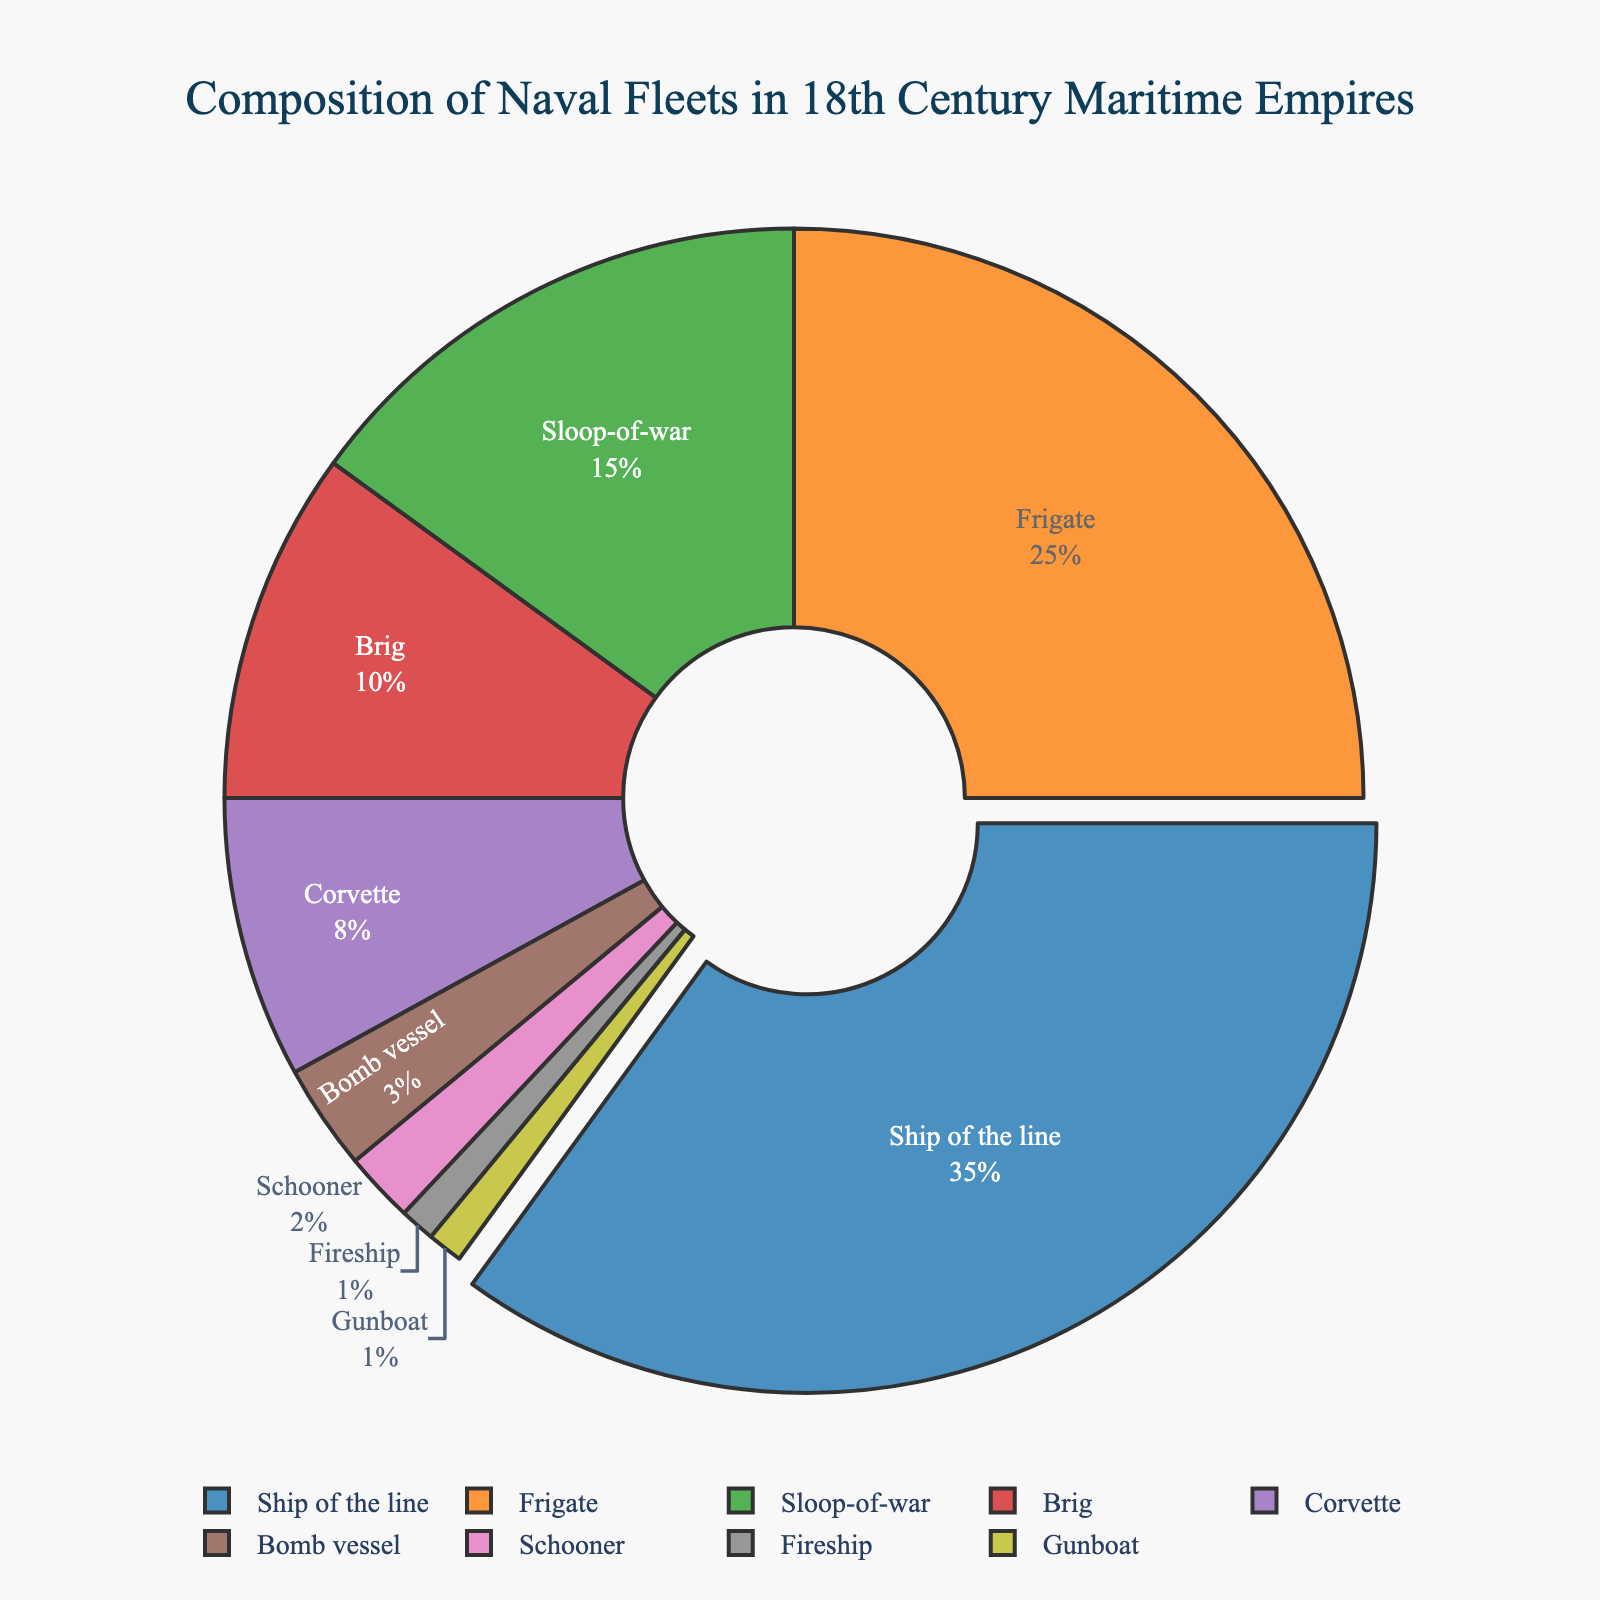What is the most common ship class in the 18th-century naval fleets? First, identify the ship class with the highest percentage in the pie chart. The "Ship of the line" makes up 35% of the fleet, which is the largest share.
Answer: Ship of the line What is the combined percentage of Brigs, Corvettes, and Bomb vessels? Add the percentages of Brigs (10%), Corvettes (8%), and Bomb vessels (3%). So, 10% + 8% + 3% = 21%.
Answer: 21% Are Frigates more common than Sloops-of-war, and by what percentage? Compare the percentages of Frigates (25%) and Sloops-of-war (15%). The difference is 25% - 15% = 10%.
Answer: Yes, by 10% What percentage of the fleet is made up by the three least common ship classes? Identify the three least common ship classes: Fireship (1%), Gunboat (1%), and Schooner (2%). The combined percentage is 1% + 1% + 2% = 4%.
Answer: 4% Which ship classes together make up more than half of the fleet's composition? Add the percentages iteratively until the sum exceeds 50%. Ships of the line (35%) + Frigates (25%) = 60%.
Answer: Ships of the line and Frigates Which ship class is represented by the green color in the pie chart? In the pie chart, each segment is color-coded. According to the provided data, the third listed class after the corresponding colors (‘#2ca02c’) would be the Sloop-of-war, which is green.
Answer: Sloop-of-war What is the difference in percentage between Brigs and Corvettes? Compare the percentages of Brigs (10%) and Corvettes (8%). The difference is 10% - 8% = 2%.
Answer: 2% What percentage of the naval fleet is comprised of smaller vessels (Schooner, Fireship, and Gunboat)? Add the percentages of Schooner (2%), Fireship (1%), and Gunboat (1%). The sum is 2% + 1% + 1% = 4%.
Answer: 4% How does the percentage of Ships of the line compare to the combined percentage of Corvettes and Bomb vessels? Ships of the line are 35%. The combined percentage of Corvettes (8%) and Bomb vessels (3%) is 8% + 3% = 11%. Compare 35% and 11%.
Answer: 35% > 11% 